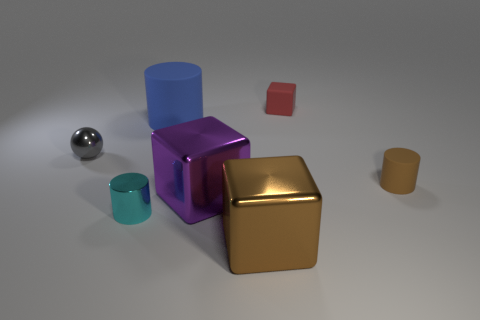There is a large block right of the large metallic object that is behind the tiny cylinder to the left of the blue cylinder; what is it made of?
Offer a terse response. Metal. There is a object that is the same color as the small rubber cylinder; what is it made of?
Your response must be concise. Metal. How many purple cylinders are made of the same material as the large brown object?
Provide a succinct answer. 0. There is a matte object that is on the right side of the red rubber thing; is it the same size as the purple thing?
Offer a terse response. No. What color is the other cube that is the same material as the large purple cube?
Your response must be concise. Brown. Is there any other thing that has the same size as the metallic ball?
Offer a terse response. Yes. What number of small brown matte cylinders are behind the tiny matte cube?
Provide a succinct answer. 0. There is a tiny metal thing that is on the right side of the tiny gray metallic thing; does it have the same color as the big shiny block that is behind the brown cube?
Ensure brevity in your answer.  No. There is another rubber object that is the same shape as the big purple object; what color is it?
Your answer should be compact. Red. Are there any other things that have the same shape as the tiny brown matte object?
Keep it short and to the point. Yes. 